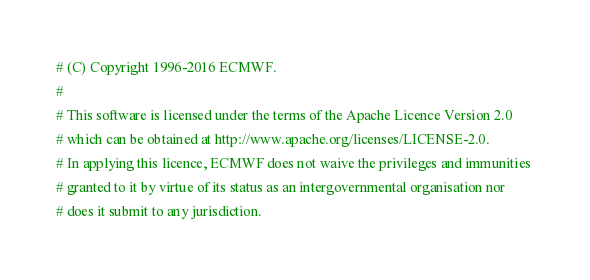Convert code to text. <code><loc_0><loc_0><loc_500><loc_500><_Python_># (C) Copyright 1996-2016 ECMWF.
# 
# This software is licensed under the terms of the Apache Licence Version 2.0
# which can be obtained at http://www.apache.org/licenses/LICENSE-2.0. 
# In applying this licence, ECMWF does not waive the privileges and immunities 
# granted to it by virtue of its status as an intergovernmental organisation nor
# does it submit to any jurisdiction.

</code> 